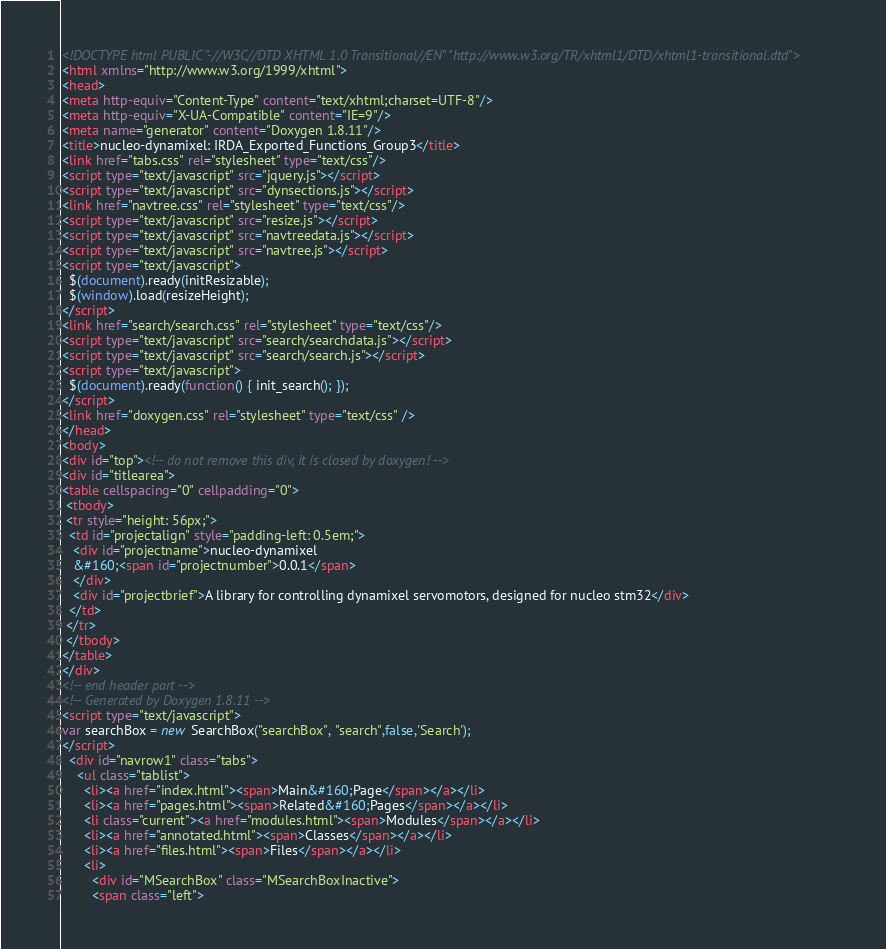Convert code to text. <code><loc_0><loc_0><loc_500><loc_500><_HTML_><!DOCTYPE html PUBLIC "-//W3C//DTD XHTML 1.0 Transitional//EN" "http://www.w3.org/TR/xhtml1/DTD/xhtml1-transitional.dtd">
<html xmlns="http://www.w3.org/1999/xhtml">
<head>
<meta http-equiv="Content-Type" content="text/xhtml;charset=UTF-8"/>
<meta http-equiv="X-UA-Compatible" content="IE=9"/>
<meta name="generator" content="Doxygen 1.8.11"/>
<title>nucleo-dynamixel: IRDA_Exported_Functions_Group3</title>
<link href="tabs.css" rel="stylesheet" type="text/css"/>
<script type="text/javascript" src="jquery.js"></script>
<script type="text/javascript" src="dynsections.js"></script>
<link href="navtree.css" rel="stylesheet" type="text/css"/>
<script type="text/javascript" src="resize.js"></script>
<script type="text/javascript" src="navtreedata.js"></script>
<script type="text/javascript" src="navtree.js"></script>
<script type="text/javascript">
  $(document).ready(initResizable);
  $(window).load(resizeHeight);
</script>
<link href="search/search.css" rel="stylesheet" type="text/css"/>
<script type="text/javascript" src="search/searchdata.js"></script>
<script type="text/javascript" src="search/search.js"></script>
<script type="text/javascript">
  $(document).ready(function() { init_search(); });
</script>
<link href="doxygen.css" rel="stylesheet" type="text/css" />
</head>
<body>
<div id="top"><!-- do not remove this div, it is closed by doxygen! -->
<div id="titlearea">
<table cellspacing="0" cellpadding="0">
 <tbody>
 <tr style="height: 56px;">
  <td id="projectalign" style="padding-left: 0.5em;">
   <div id="projectname">nucleo-dynamixel
   &#160;<span id="projectnumber">0.0.1</span>
   </div>
   <div id="projectbrief">A library for controlling dynamixel servomotors, designed for nucleo stm32</div>
  </td>
 </tr>
 </tbody>
</table>
</div>
<!-- end header part -->
<!-- Generated by Doxygen 1.8.11 -->
<script type="text/javascript">
var searchBox = new SearchBox("searchBox", "search",false,'Search');
</script>
  <div id="navrow1" class="tabs">
    <ul class="tablist">
      <li><a href="index.html"><span>Main&#160;Page</span></a></li>
      <li><a href="pages.html"><span>Related&#160;Pages</span></a></li>
      <li class="current"><a href="modules.html"><span>Modules</span></a></li>
      <li><a href="annotated.html"><span>Classes</span></a></li>
      <li><a href="files.html"><span>Files</span></a></li>
      <li>
        <div id="MSearchBox" class="MSearchBoxInactive">
        <span class="left"></code> 